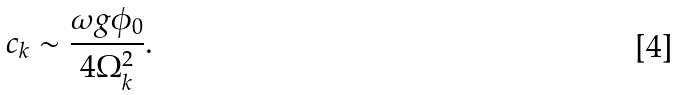Convert formula to latex. <formula><loc_0><loc_0><loc_500><loc_500>c _ { k } \sim \frac { \omega g \phi _ { 0 } } { 4 \Omega _ { k } ^ { 2 } } .</formula> 